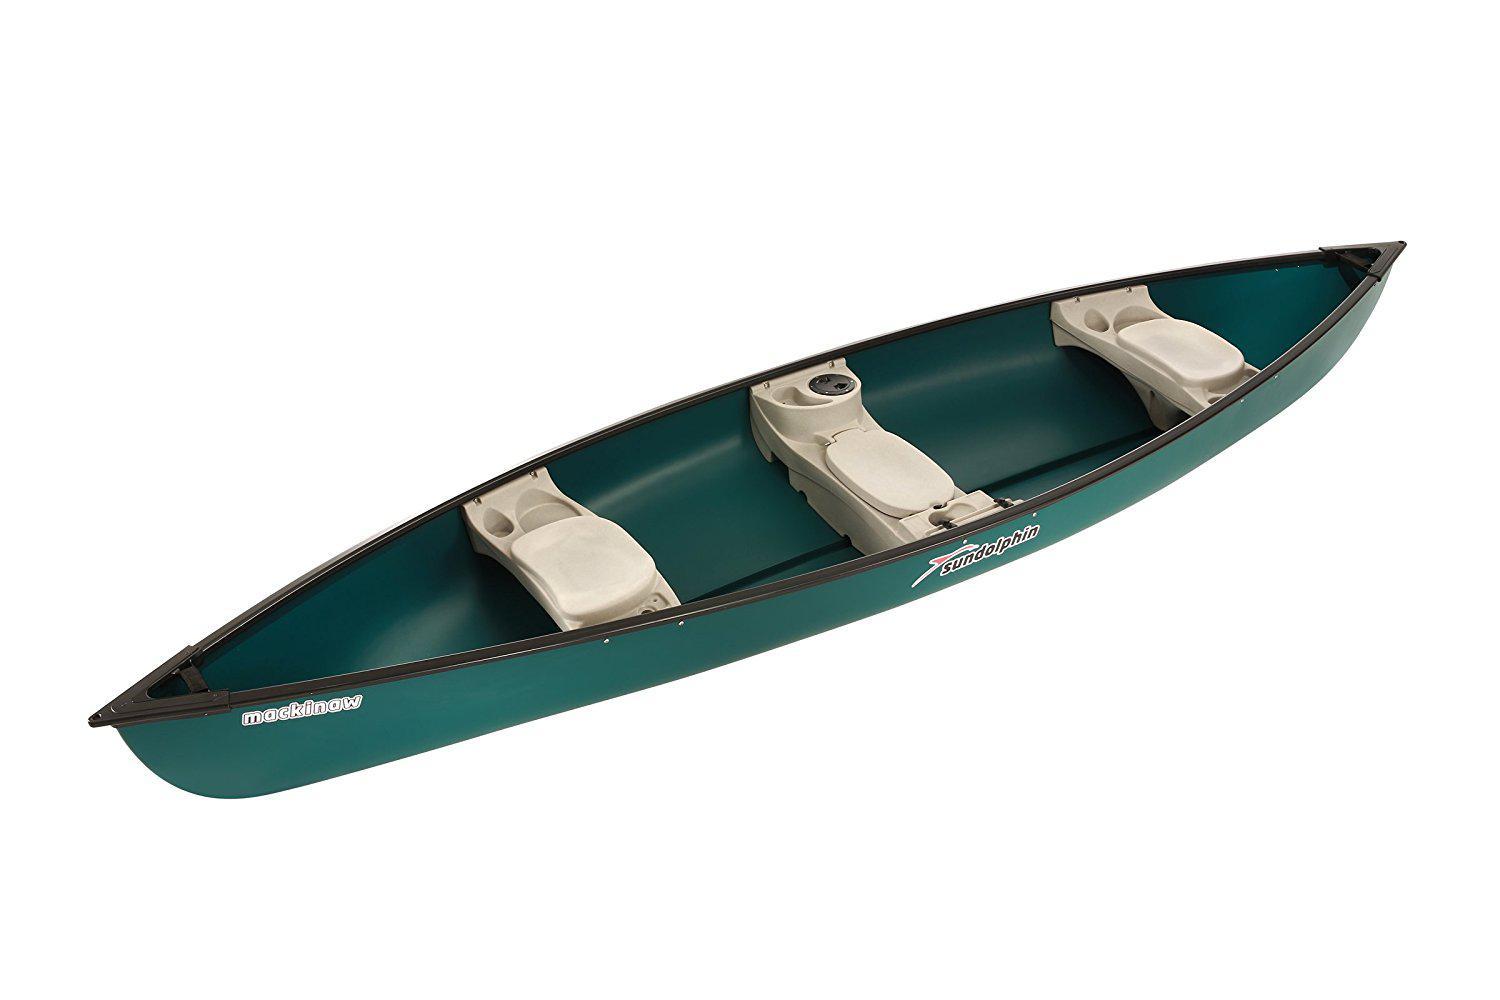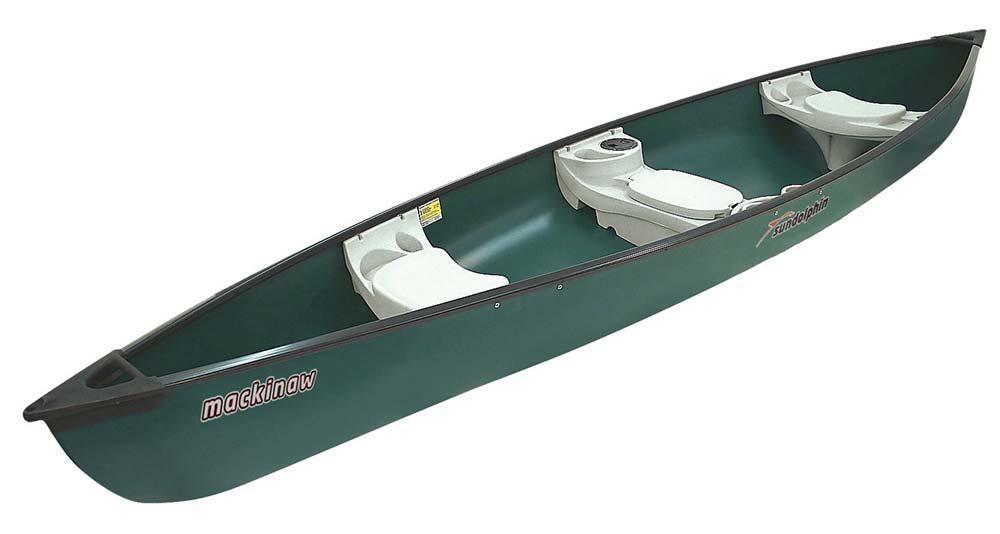The first image is the image on the left, the second image is the image on the right. Examine the images to the left and right. Is the description "there are 6 seats in the canoe  in the image pair" accurate? Answer yes or no. Yes. 